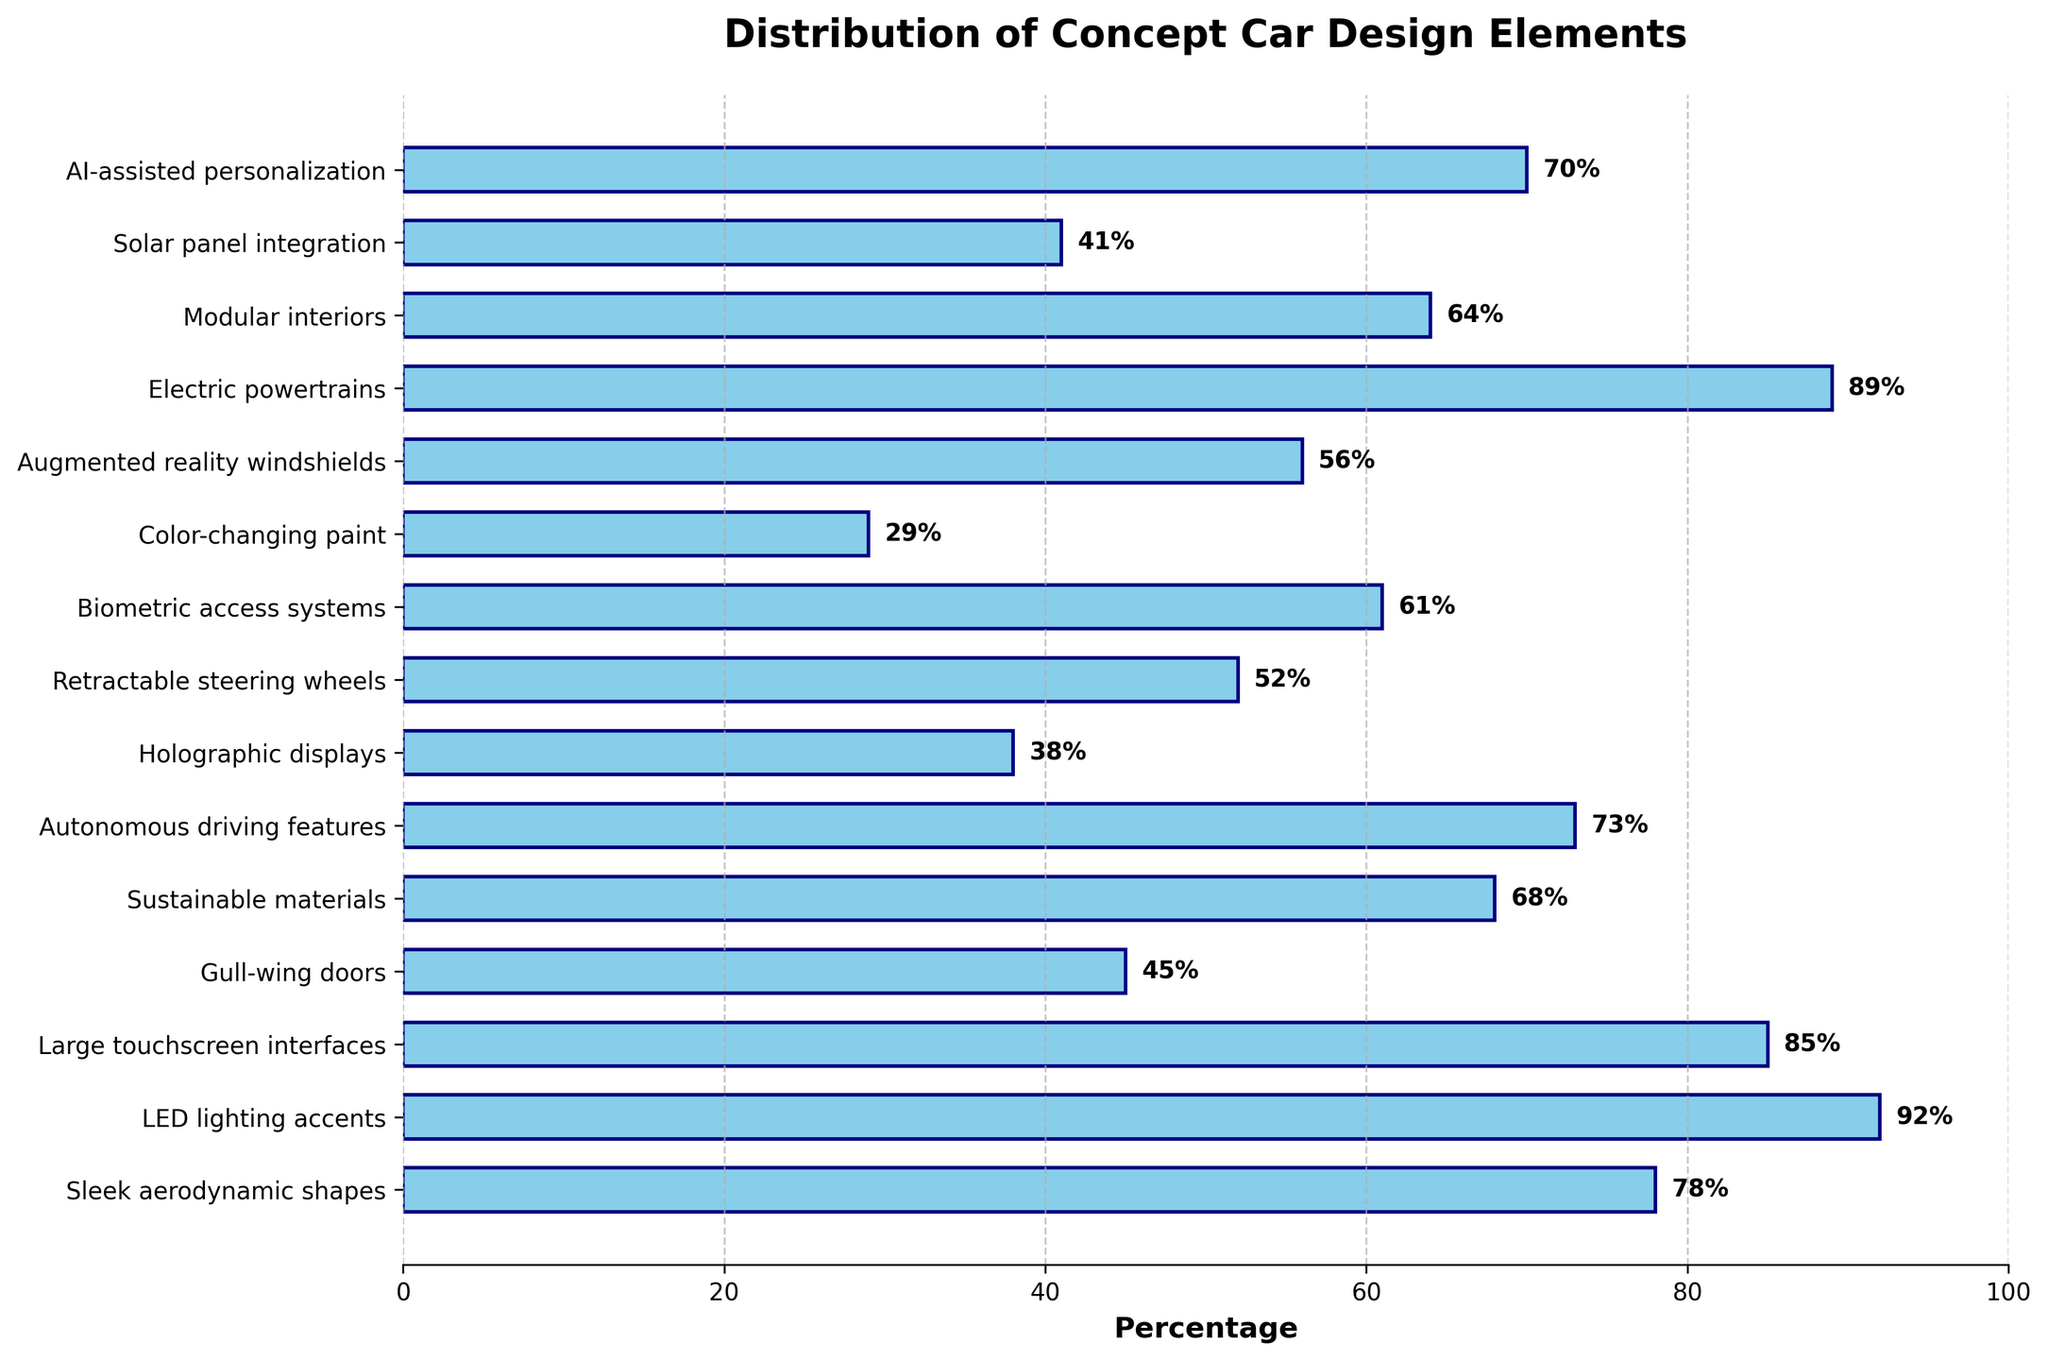What percentage of concept cars feature LED lighting accents? The figure shows the percentage for each design element. For LED lighting accents, the bar extends to 92%.
Answer: 92% Which design elements have a percentage higher than 80%? The figure indicates the percentage for each element. Elements with percentages higher than 80% are LED lighting accents (92%), Large touchscreen interfaces (85%), and Electric powertrains (89%).
Answer: LED lighting accents, Large touchscreen interfaces, Electric powertrains What is the difference in percentage between Augmented reality windshields and Holographic displays? The percentage for Augmented reality windshields is 56%, and for Holographic displays, it's 38%. The difference is 56% - 38% = 18%.
Answer: 18% Which element has the lowest presence in concept cars? The figure shows the percentage for each element. Color-changing paint has the lowest percentage at 29%.
Answer: Color-changing paint How many design elements have a percentage between 40% and 60% inclusive? The design elements with percentages between 40% and 60% are Gull-wing doors (45%), Solar panel integration (41%), Retractable steering wheels (52%), and Augmented reality windshields (56%), totaling 4 elements.
Answer: 4 What is the average percentage of Autonomous driving features and AI-assisted personalization? The percentages are 73% for Autonomous driving features and 70% for AI-assisted personalization. The average is (73% + 70%) / 2 = 71.5%.
Answer: 71.5% Which element is more popular, Modular interiors or Sustainable materials? From the figure, Modular interiors have a percentage of 64%, whereas Sustainable materials have 68%. Thus, Sustainable materials are more popular.
Answer: Sustainable materials Are more concept cars featuring Biometric access systems or Gull-wing doors? The figure shows Biometric access systems at 61% and Gull-wing doors at 45%. Consequently, more concept cars feature Biometric access systems.
Answer: Biometric access systems What is the median percentage of the design elements? To find the median, list the percentages in ascending order: 29, 38, 41, 45, 52, 56, 61, 64, 68, 70, 73, 78, 85, 89, 92. The middle value (8th in order) is 64%.
Answer: 64% Which element has a similar presence to Retractable steering wheels in concept cars? The figure shows that Retractable steering wheels have a percentage of 52%. Augmented reality windshields have a similar presence at 56%.
Answer: Augmented reality windshields 